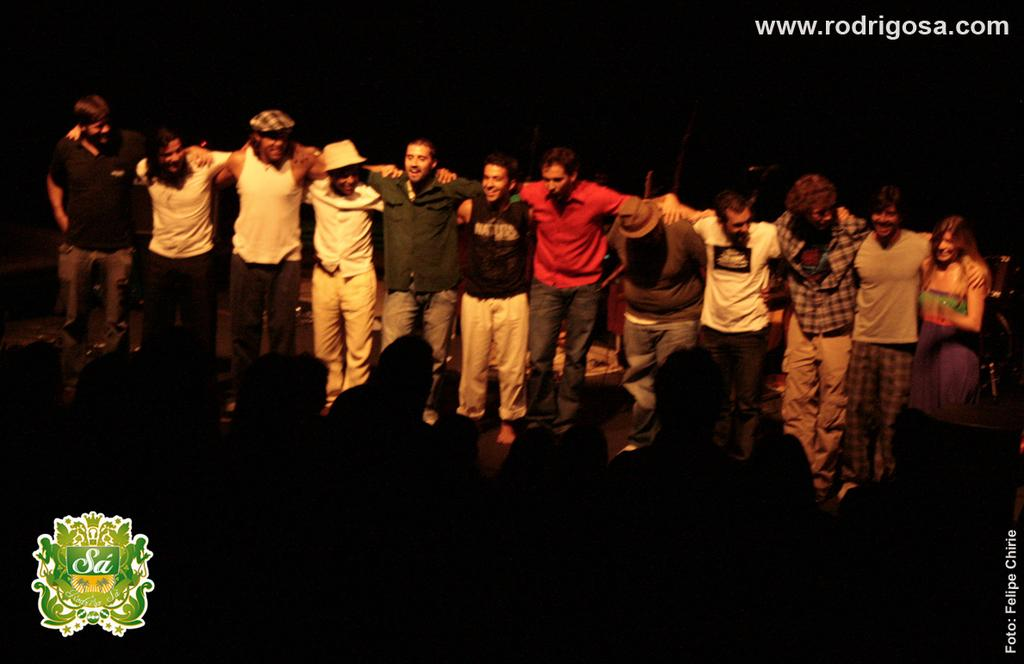What is happening in the center of the image? There is a group of persons standing in the center of the image. What is the facial expression of the persons in the image? The persons are smiling. Are there any persons in the foreground of the image? Yes, there are persons in the front of the image. What can be seen at the top of the image? There is some text written at the top of the image. Can you tell me how many donkeys are present in the image? There are no donkeys present in the image. What type of carpenter is working in the background of the image? There is no carpenter or any indication of carpentry work in the image. 